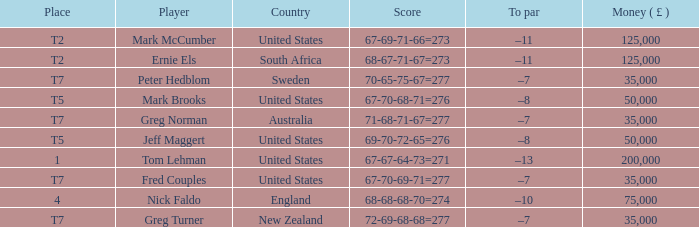What is the highest Money ( £ ), when Player is "Peter Hedblom"? 35000.0. 